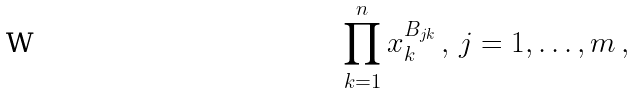<formula> <loc_0><loc_0><loc_500><loc_500>\prod _ { k = 1 } ^ { n } x _ { k } ^ { B _ { j k } } \, , \, j = 1 , \dots , m \, ,</formula> 